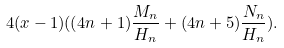Convert formula to latex. <formula><loc_0><loc_0><loc_500><loc_500>4 ( x - 1 ) ( ( 4 n + 1 ) \frac { M _ { n } } { H _ { n } } + ( 4 n + 5 ) \frac { N _ { n } } { H _ { n } } ) .</formula> 